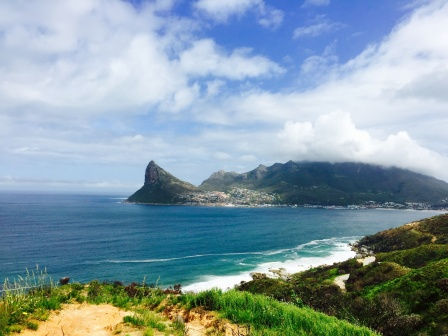Describe a realistic scenario where tourists might enjoy this area. Tourists visiting this picturesque coastal town might start their day with a leisurely breakfast at a quaint local cafe, enjoying freshly baked pastries and aromatic coffee while gazing out at the sparkling ocean. Following their meal, they might embark on a guided tour of the scenic hills, learning about the area's rich history and diverse flora and fauna from knowledgeable guides.

In the afternoon, tourists could take a relaxing boat ride along the coastline, where they might spot playful dolphins and marvel at the stunning rock formations. For those seeking adventure, water sports like snorkeling, kayaking, or paddleboarding could offer an exhilarating way to explore the ocean's beauty up close.

As the sun begins to set, the tourists might gather on the beach for a bonfire, where they can share stories, roast marshmallows, and enjoy the serene sound of waves lapping the shore. The clear night sky could offer a perfect opportunity for stargazing, with the distant lights of the small town adding a charming backdrop to the evening's festivities. This realistic scenario highlights the diverse and enjoyable experiences that tourists could have in this captivating coastal setting. 